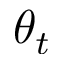Convert formula to latex. <formula><loc_0><loc_0><loc_500><loc_500>\theta _ { t }</formula> 